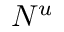<formula> <loc_0><loc_0><loc_500><loc_500>N ^ { u }</formula> 